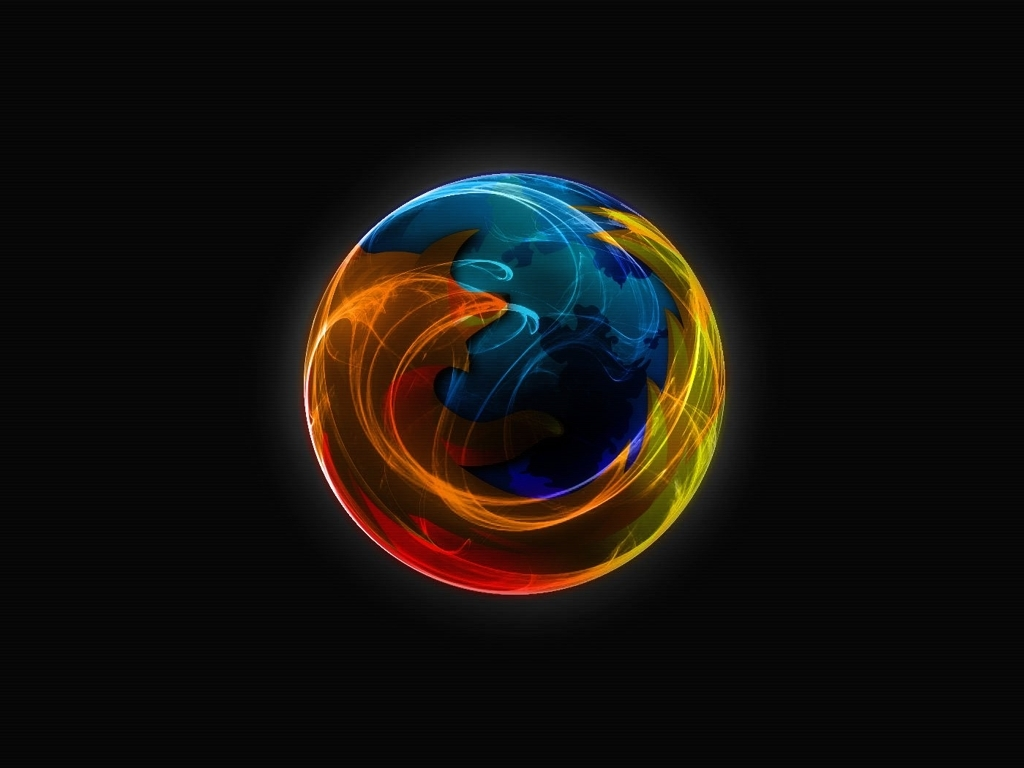Is the overall quality of the image satisfactory? The image presents a high-resolution depiction with vibrant color contrasts and dynamic compositions, providing a visually appealing and sharp quality that should be satisfactory for both digital and print use. 